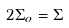<formula> <loc_0><loc_0><loc_500><loc_500>2 \Sigma _ { o } = \Sigma</formula> 